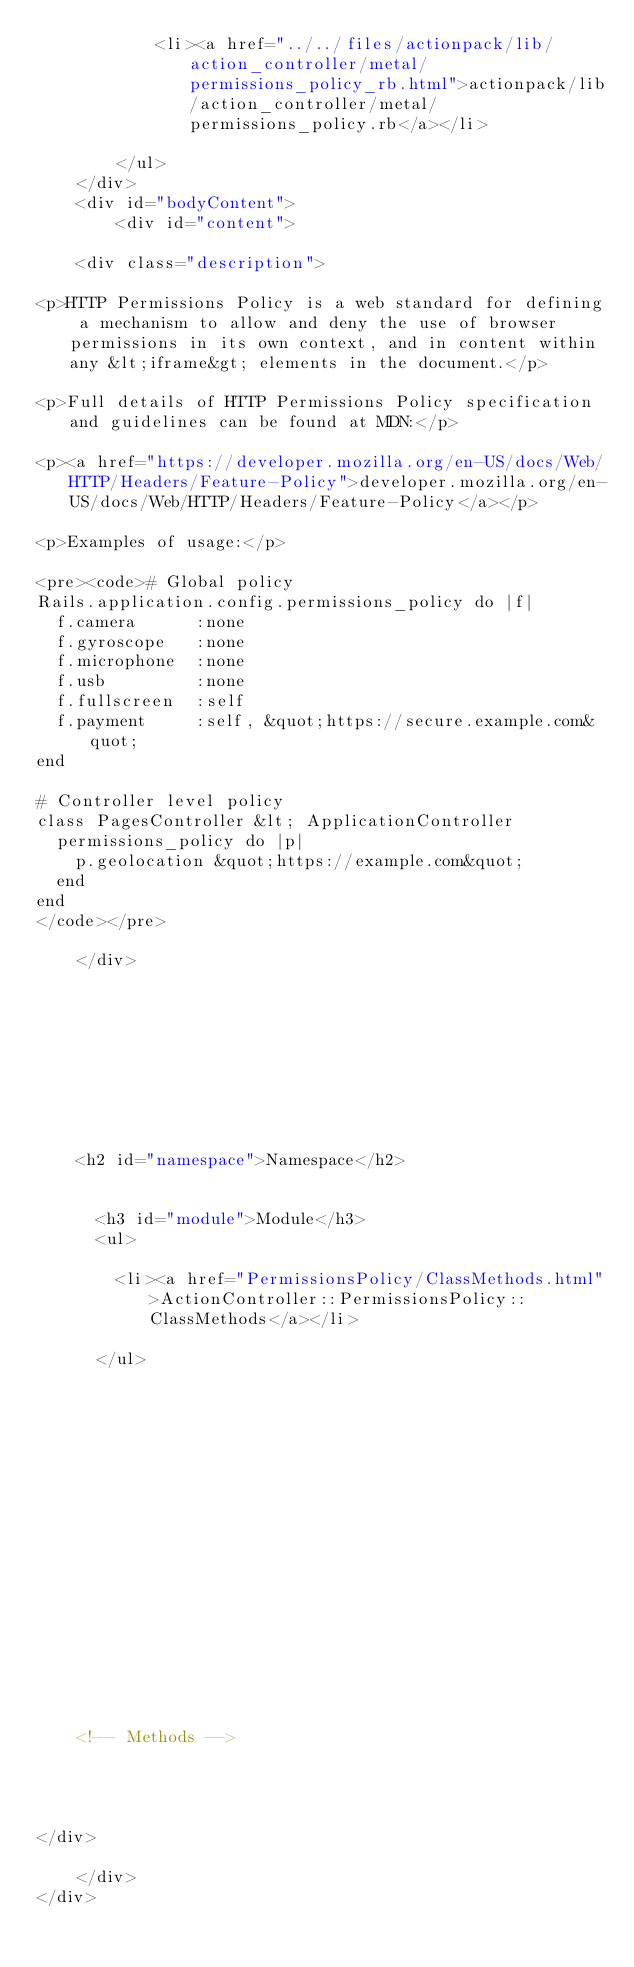<code> <loc_0><loc_0><loc_500><loc_500><_HTML_>            <li><a href="../../files/actionpack/lib/action_controller/metal/permissions_policy_rb.html">actionpack/lib/action_controller/metal/permissions_policy.rb</a></li>
            
        </ul>
    </div>
    <div id="bodyContent">
        <div id="content">
  
    <div class="description">
      
<p>HTTP Permissions Policy is a web standard for defining a mechanism to allow and deny the use of browser permissions in its own context, and in content within any &lt;iframe&gt; elements in the document.</p>

<p>Full details of HTTP Permissions Policy specification and guidelines can be found at MDN:</p>

<p><a href="https://developer.mozilla.org/en-US/docs/Web/HTTP/Headers/Feature-Policy">developer.mozilla.org/en-US/docs/Web/HTTP/Headers/Feature-Policy</a></p>

<p>Examples of usage:</p>

<pre><code># Global policy
Rails.application.config.permissions_policy do |f|
  f.camera      :none
  f.gyroscope   :none
  f.microphone  :none
  f.usb         :none
  f.fullscreen  :self
  f.payment     :self, &quot;https://secure.example.com&quot;
end

# Controller level policy
class PagesController &lt; ApplicationController
  permissions_policy do |p|
    p.geolocation &quot;https://example.com&quot;
  end
end
</code></pre>

    </div>
  

  

  
  


  
    <h2 id="namespace">Namespace</h2>

    
      <h3 id="module">Module</h3>
      <ul>
      
        <li><a href="PermissionsPolicy/ClassMethods.html">ActionController::PermissionsPolicy::ClassMethods</a></li>
      
      </ul>
    

    
  

  

  

  
    

    

    

    

    <!-- Methods -->
    
    
    
  
</div>

    </div>
</div>
</code> 